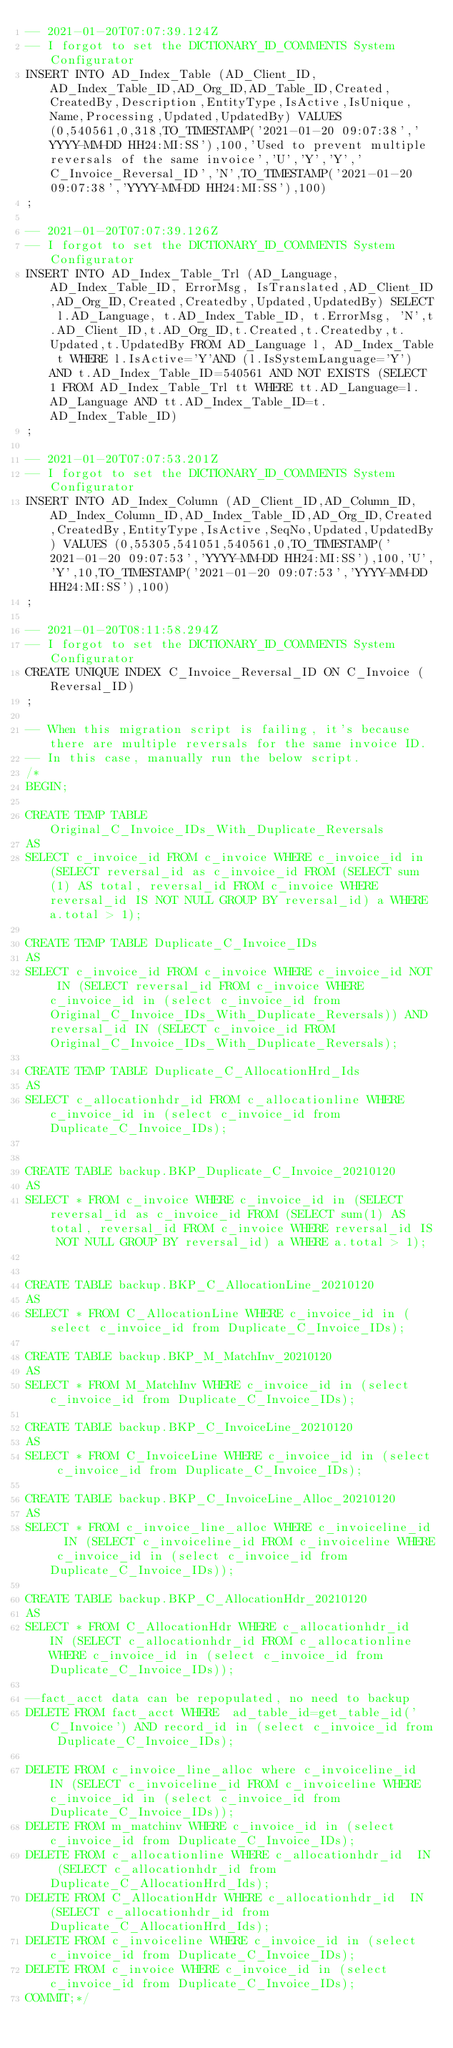Convert code to text. <code><loc_0><loc_0><loc_500><loc_500><_SQL_>-- 2021-01-20T07:07:39.124Z
-- I forgot to set the DICTIONARY_ID_COMMENTS System Configurator
INSERT INTO AD_Index_Table (AD_Client_ID,AD_Index_Table_ID,AD_Org_ID,AD_Table_ID,Created,CreatedBy,Description,EntityType,IsActive,IsUnique,Name,Processing,Updated,UpdatedBy) VALUES (0,540561,0,318,TO_TIMESTAMP('2021-01-20 09:07:38','YYYY-MM-DD HH24:MI:SS'),100,'Used to prevent multiple reversals of the same invoice','U','Y','Y','C_Invoice_Reversal_ID','N',TO_TIMESTAMP('2021-01-20 09:07:38','YYYY-MM-DD HH24:MI:SS'),100)
;

-- 2021-01-20T07:07:39.126Z
-- I forgot to set the DICTIONARY_ID_COMMENTS System Configurator
INSERT INTO AD_Index_Table_Trl (AD_Language,AD_Index_Table_ID, ErrorMsg, IsTranslated,AD_Client_ID,AD_Org_ID,Created,Createdby,Updated,UpdatedBy) SELECT l.AD_Language, t.AD_Index_Table_ID, t.ErrorMsg, 'N',t.AD_Client_ID,t.AD_Org_ID,t.Created,t.Createdby,t.Updated,t.UpdatedBy FROM AD_Language l, AD_Index_Table t WHERE l.IsActive='Y'AND (l.IsSystemLanguage='Y') AND t.AD_Index_Table_ID=540561 AND NOT EXISTS (SELECT 1 FROM AD_Index_Table_Trl tt WHERE tt.AD_Language=l.AD_Language AND tt.AD_Index_Table_ID=t.AD_Index_Table_ID)
;

-- 2021-01-20T07:07:53.201Z
-- I forgot to set the DICTIONARY_ID_COMMENTS System Configurator
INSERT INTO AD_Index_Column (AD_Client_ID,AD_Column_ID,AD_Index_Column_ID,AD_Index_Table_ID,AD_Org_ID,Created,CreatedBy,EntityType,IsActive,SeqNo,Updated,UpdatedBy) VALUES (0,55305,541051,540561,0,TO_TIMESTAMP('2021-01-20 09:07:53','YYYY-MM-DD HH24:MI:SS'),100,'U','Y',10,TO_TIMESTAMP('2021-01-20 09:07:53','YYYY-MM-DD HH24:MI:SS'),100)
;

-- 2021-01-20T08:11:58.294Z
-- I forgot to set the DICTIONARY_ID_COMMENTS System Configurator
CREATE UNIQUE INDEX C_Invoice_Reversal_ID ON C_Invoice (Reversal_ID)
;

-- When this migration script is failing, it's because there are multiple reversals for the same invoice ID.
-- In this case, manually run the below script.
/*
BEGIN;

CREATE TEMP TABLE Original_C_Invoice_IDs_With_Duplicate_Reversals
AS
SELECT c_invoice_id FROM c_invoice WHERE c_invoice_id in (SELECT reversal_id as c_invoice_id FROM (SELECT sum(1) AS total, reversal_id FROM c_invoice WHERE reversal_id IS NOT NULL GROUP BY reversal_id) a WHERE a.total > 1);

CREATE TEMP TABLE Duplicate_C_Invoice_IDs
AS
SELECT c_invoice_id FROM c_invoice WHERE c_invoice_id NOT IN (SELECT reversal_id FROM c_invoice WHERE c_invoice_id in (select c_invoice_id from Original_C_Invoice_IDs_With_Duplicate_Reversals)) AND reversal_id IN (SELECT c_invoice_id FROM Original_C_Invoice_IDs_With_Duplicate_Reversals);

CREATE TEMP TABLE Duplicate_C_AllocationHrd_Ids
AS
SELECT c_allocationhdr_id FROM c_allocationline WHERE c_invoice_id in (select c_invoice_id from Duplicate_C_Invoice_IDs);


CREATE TABLE backup.BKP_Duplicate_C_Invoice_20210120
AS
SELECT * FROM c_invoice WHERE c_invoice_id in (SELECT reversal_id as c_invoice_id FROM (SELECT sum(1) AS total, reversal_id FROM c_invoice WHERE reversal_id IS NOT NULL GROUP BY reversal_id) a WHERE a.total > 1);


CREATE TABLE backup.BKP_C_AllocationLine_20210120
AS
SELECT * FROM C_AllocationLine WHERE c_invoice_id in (select c_invoice_id from Duplicate_C_Invoice_IDs);

CREATE TABLE backup.BKP_M_MatchInv_20210120
AS
SELECT * FROM M_MatchInv WHERE c_invoice_id in (select c_invoice_id from Duplicate_C_Invoice_IDs);

CREATE TABLE backup.BKP_C_InvoiceLine_20210120
AS
SELECT * FROM C_InvoiceLine WHERE c_invoice_id in (select c_invoice_id from Duplicate_C_Invoice_IDs);

CREATE TABLE backup.BKP_C_InvoiceLine_Alloc_20210120
AS
SELECT * FROM c_invoice_line_alloc WHERE c_invoiceline_id  IN (SELECT c_invoiceline_id FROM c_invoiceline WHERE c_invoice_id in (select c_invoice_id from Duplicate_C_Invoice_IDs));

CREATE TABLE backup.BKP_C_AllocationHdr_20210120
AS
SELECT * FROM C_AllocationHdr WHERE c_allocationhdr_id  IN (SELECT c_allocationhdr_id FROM c_allocationline WHERE c_invoice_id in (select c_invoice_id from Duplicate_C_Invoice_IDs));

--fact_acct data can be repopulated, no need to backup
DELETE FROM fact_acct WHERE  ad_table_id=get_table_id('C_Invoice') AND record_id in (select c_invoice_id from Duplicate_C_Invoice_IDs);

DELETE FROM c_invoice_line_alloc where c_invoiceline_id IN (SELECT c_invoiceline_id FROM c_invoiceline WHERE c_invoice_id in (select c_invoice_id from Duplicate_C_Invoice_IDs));
DELETE FROM m_matchinv WHERE c_invoice_id in (select c_invoice_id from Duplicate_C_Invoice_IDs);
DELETE FROM c_allocationline WHERE c_allocationhdr_id  IN (SELECT c_allocationhdr_id from Duplicate_C_AllocationHrd_Ids);
DELETE FROM C_AllocationHdr WHERE c_allocationhdr_id  IN (SELECT c_allocationhdr_id from Duplicate_C_AllocationHrd_Ids);
DELETE FROM c_invoiceline WHERE c_invoice_id in (select c_invoice_id from Duplicate_C_Invoice_IDs);
DELETE FROM c_invoice WHERE c_invoice_id in (select c_invoice_id from Duplicate_C_Invoice_IDs);
COMMIT;*/</code> 